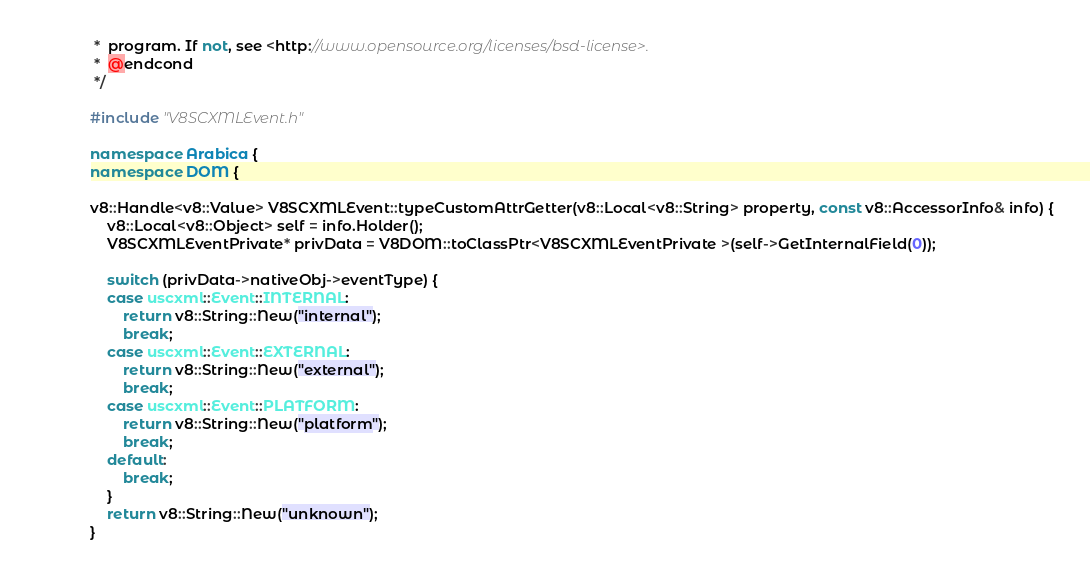<code> <loc_0><loc_0><loc_500><loc_500><_C++_> *  program. If not, see <http://www.opensource.org/licenses/bsd-license>.
 *  @endcond
 */

#include "V8SCXMLEvent.h"

namespace Arabica {
namespace DOM {

v8::Handle<v8::Value> V8SCXMLEvent::typeCustomAttrGetter(v8::Local<v8::String> property, const v8::AccessorInfo& info) {
	v8::Local<v8::Object> self = info.Holder();
	V8SCXMLEventPrivate* privData = V8DOM::toClassPtr<V8SCXMLEventPrivate >(self->GetInternalField(0));

	switch (privData->nativeObj->eventType) {
	case uscxml::Event::INTERNAL:
		return v8::String::New("internal");
		break;
	case uscxml::Event::EXTERNAL:
		return v8::String::New("external");
		break;
	case uscxml::Event::PLATFORM:
		return v8::String::New("platform");
		break;
	default:
		break;
	}
	return v8::String::New("unknown");
}
</code> 